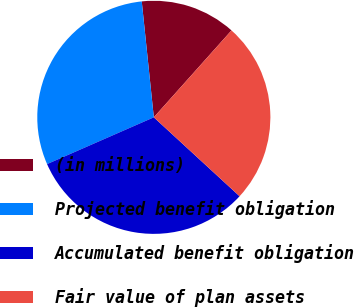Convert chart to OTSL. <chart><loc_0><loc_0><loc_500><loc_500><pie_chart><fcel>(in millions)<fcel>Projected benefit obligation<fcel>Accumulated benefit obligation<fcel>Fair value of plan assets<nl><fcel>13.26%<fcel>29.92%<fcel>31.59%<fcel>25.23%<nl></chart> 